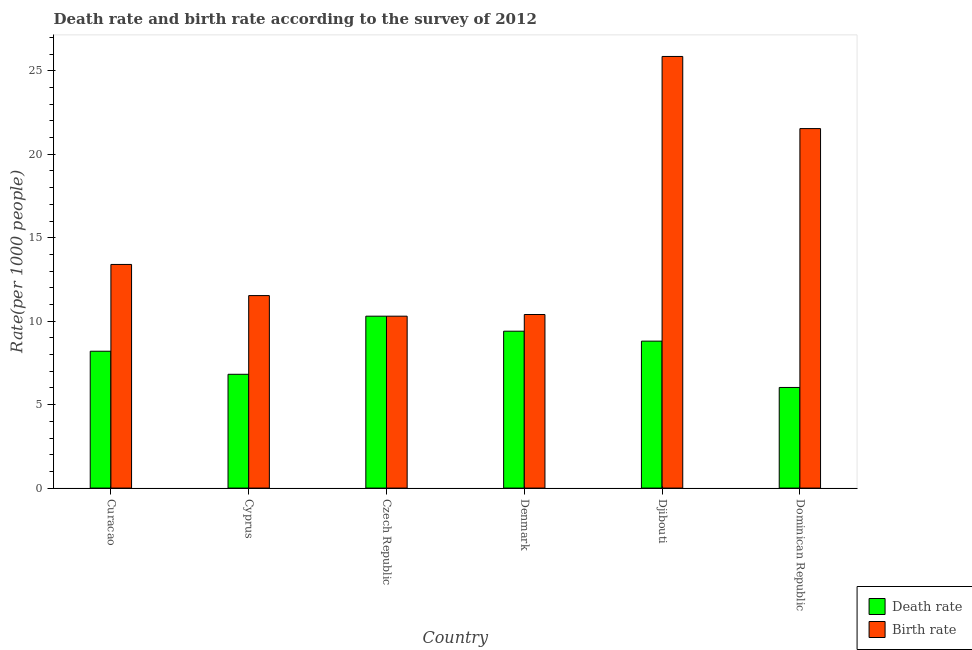How many different coloured bars are there?
Provide a succinct answer. 2. How many bars are there on the 4th tick from the left?
Your response must be concise. 2. How many bars are there on the 6th tick from the right?
Give a very brief answer. 2. What is the label of the 1st group of bars from the left?
Your answer should be compact. Curacao. What is the birth rate in Czech Republic?
Keep it short and to the point. 10.3. Across all countries, what is the maximum death rate?
Provide a succinct answer. 10.3. In which country was the death rate maximum?
Ensure brevity in your answer.  Czech Republic. In which country was the death rate minimum?
Offer a terse response. Dominican Republic. What is the total birth rate in the graph?
Provide a short and direct response. 93.03. What is the difference between the birth rate in Denmark and that in Dominican Republic?
Your answer should be compact. -11.14. What is the difference between the death rate in Curacao and the birth rate in Czech Republic?
Offer a terse response. -2.1. What is the average death rate per country?
Give a very brief answer. 8.26. What is the difference between the death rate and birth rate in Curacao?
Keep it short and to the point. -5.2. What is the ratio of the birth rate in Denmark to that in Dominican Republic?
Provide a succinct answer. 0.48. Is the death rate in Denmark less than that in Dominican Republic?
Your answer should be very brief. No. What is the difference between the highest and the second highest death rate?
Give a very brief answer. 0.9. What is the difference between the highest and the lowest death rate?
Provide a succinct answer. 4.27. Is the sum of the birth rate in Curacao and Djibouti greater than the maximum death rate across all countries?
Offer a terse response. Yes. What does the 1st bar from the left in Denmark represents?
Provide a succinct answer. Death rate. What does the 1st bar from the right in Cyprus represents?
Your answer should be very brief. Birth rate. What is the difference between two consecutive major ticks on the Y-axis?
Provide a succinct answer. 5. Does the graph contain any zero values?
Your answer should be compact. No. How many legend labels are there?
Provide a short and direct response. 2. How are the legend labels stacked?
Your answer should be compact. Vertical. What is the title of the graph?
Offer a very short reply. Death rate and birth rate according to the survey of 2012. What is the label or title of the Y-axis?
Your response must be concise. Rate(per 1000 people). What is the Rate(per 1000 people) of Death rate in Curacao?
Offer a very short reply. 8.2. What is the Rate(per 1000 people) in Birth rate in Curacao?
Ensure brevity in your answer.  13.4. What is the Rate(per 1000 people) of Death rate in Cyprus?
Your answer should be compact. 6.82. What is the Rate(per 1000 people) of Birth rate in Cyprus?
Ensure brevity in your answer.  11.53. What is the Rate(per 1000 people) in Death rate in Czech Republic?
Your answer should be compact. 10.3. What is the Rate(per 1000 people) of Birth rate in Czech Republic?
Offer a terse response. 10.3. What is the Rate(per 1000 people) of Death rate in Djibouti?
Provide a succinct answer. 8.8. What is the Rate(per 1000 people) in Birth rate in Djibouti?
Provide a succinct answer. 25.86. What is the Rate(per 1000 people) in Death rate in Dominican Republic?
Your response must be concise. 6.03. What is the Rate(per 1000 people) in Birth rate in Dominican Republic?
Ensure brevity in your answer.  21.54. Across all countries, what is the maximum Rate(per 1000 people) in Birth rate?
Give a very brief answer. 25.86. Across all countries, what is the minimum Rate(per 1000 people) in Death rate?
Provide a succinct answer. 6.03. Across all countries, what is the minimum Rate(per 1000 people) in Birth rate?
Offer a very short reply. 10.3. What is the total Rate(per 1000 people) in Death rate in the graph?
Offer a terse response. 49.55. What is the total Rate(per 1000 people) of Birth rate in the graph?
Your answer should be very brief. 93.03. What is the difference between the Rate(per 1000 people) in Death rate in Curacao and that in Cyprus?
Provide a succinct answer. 1.38. What is the difference between the Rate(per 1000 people) of Birth rate in Curacao and that in Cyprus?
Your answer should be compact. 1.87. What is the difference between the Rate(per 1000 people) in Death rate in Curacao and that in Czech Republic?
Your response must be concise. -2.1. What is the difference between the Rate(per 1000 people) in Death rate in Curacao and that in Djibouti?
Provide a succinct answer. -0.6. What is the difference between the Rate(per 1000 people) in Birth rate in Curacao and that in Djibouti?
Provide a short and direct response. -12.46. What is the difference between the Rate(per 1000 people) in Death rate in Curacao and that in Dominican Republic?
Your response must be concise. 2.17. What is the difference between the Rate(per 1000 people) of Birth rate in Curacao and that in Dominican Republic?
Offer a very short reply. -8.14. What is the difference between the Rate(per 1000 people) of Death rate in Cyprus and that in Czech Republic?
Provide a succinct answer. -3.48. What is the difference between the Rate(per 1000 people) of Birth rate in Cyprus and that in Czech Republic?
Give a very brief answer. 1.23. What is the difference between the Rate(per 1000 people) in Death rate in Cyprus and that in Denmark?
Ensure brevity in your answer.  -2.58. What is the difference between the Rate(per 1000 people) of Birth rate in Cyprus and that in Denmark?
Provide a succinct answer. 1.13. What is the difference between the Rate(per 1000 people) of Death rate in Cyprus and that in Djibouti?
Offer a very short reply. -1.99. What is the difference between the Rate(per 1000 people) of Birth rate in Cyprus and that in Djibouti?
Ensure brevity in your answer.  -14.33. What is the difference between the Rate(per 1000 people) in Death rate in Cyprus and that in Dominican Republic?
Offer a terse response. 0.79. What is the difference between the Rate(per 1000 people) of Birth rate in Cyprus and that in Dominican Republic?
Your answer should be compact. -10.01. What is the difference between the Rate(per 1000 people) of Birth rate in Czech Republic and that in Denmark?
Make the answer very short. -0.1. What is the difference between the Rate(per 1000 people) in Death rate in Czech Republic and that in Djibouti?
Your answer should be very brief. 1.5. What is the difference between the Rate(per 1000 people) of Birth rate in Czech Republic and that in Djibouti?
Offer a terse response. -15.56. What is the difference between the Rate(per 1000 people) in Death rate in Czech Republic and that in Dominican Republic?
Provide a short and direct response. 4.27. What is the difference between the Rate(per 1000 people) in Birth rate in Czech Republic and that in Dominican Republic?
Give a very brief answer. -11.24. What is the difference between the Rate(per 1000 people) of Death rate in Denmark and that in Djibouti?
Your answer should be very brief. 0.59. What is the difference between the Rate(per 1000 people) in Birth rate in Denmark and that in Djibouti?
Your answer should be very brief. -15.46. What is the difference between the Rate(per 1000 people) in Death rate in Denmark and that in Dominican Republic?
Offer a terse response. 3.37. What is the difference between the Rate(per 1000 people) of Birth rate in Denmark and that in Dominican Republic?
Provide a short and direct response. -11.14. What is the difference between the Rate(per 1000 people) of Death rate in Djibouti and that in Dominican Republic?
Offer a very short reply. 2.78. What is the difference between the Rate(per 1000 people) in Birth rate in Djibouti and that in Dominican Republic?
Ensure brevity in your answer.  4.32. What is the difference between the Rate(per 1000 people) in Death rate in Curacao and the Rate(per 1000 people) in Birth rate in Cyprus?
Ensure brevity in your answer.  -3.33. What is the difference between the Rate(per 1000 people) in Death rate in Curacao and the Rate(per 1000 people) in Birth rate in Djibouti?
Make the answer very short. -17.66. What is the difference between the Rate(per 1000 people) in Death rate in Curacao and the Rate(per 1000 people) in Birth rate in Dominican Republic?
Offer a very short reply. -13.34. What is the difference between the Rate(per 1000 people) of Death rate in Cyprus and the Rate(per 1000 people) of Birth rate in Czech Republic?
Provide a succinct answer. -3.48. What is the difference between the Rate(per 1000 people) of Death rate in Cyprus and the Rate(per 1000 people) of Birth rate in Denmark?
Your answer should be compact. -3.58. What is the difference between the Rate(per 1000 people) in Death rate in Cyprus and the Rate(per 1000 people) in Birth rate in Djibouti?
Make the answer very short. -19.04. What is the difference between the Rate(per 1000 people) of Death rate in Cyprus and the Rate(per 1000 people) of Birth rate in Dominican Republic?
Your answer should be compact. -14.72. What is the difference between the Rate(per 1000 people) of Death rate in Czech Republic and the Rate(per 1000 people) of Birth rate in Djibouti?
Offer a terse response. -15.56. What is the difference between the Rate(per 1000 people) of Death rate in Czech Republic and the Rate(per 1000 people) of Birth rate in Dominican Republic?
Your response must be concise. -11.24. What is the difference between the Rate(per 1000 people) in Death rate in Denmark and the Rate(per 1000 people) in Birth rate in Djibouti?
Your response must be concise. -16.46. What is the difference between the Rate(per 1000 people) of Death rate in Denmark and the Rate(per 1000 people) of Birth rate in Dominican Republic?
Give a very brief answer. -12.14. What is the difference between the Rate(per 1000 people) in Death rate in Djibouti and the Rate(per 1000 people) in Birth rate in Dominican Republic?
Your answer should be compact. -12.73. What is the average Rate(per 1000 people) of Death rate per country?
Provide a succinct answer. 8.26. What is the average Rate(per 1000 people) of Birth rate per country?
Provide a succinct answer. 15.51. What is the difference between the Rate(per 1000 people) in Death rate and Rate(per 1000 people) in Birth rate in Curacao?
Offer a terse response. -5.2. What is the difference between the Rate(per 1000 people) in Death rate and Rate(per 1000 people) in Birth rate in Cyprus?
Ensure brevity in your answer.  -4.72. What is the difference between the Rate(per 1000 people) in Death rate and Rate(per 1000 people) in Birth rate in Czech Republic?
Provide a short and direct response. 0. What is the difference between the Rate(per 1000 people) of Death rate and Rate(per 1000 people) of Birth rate in Djibouti?
Give a very brief answer. -17.06. What is the difference between the Rate(per 1000 people) in Death rate and Rate(per 1000 people) in Birth rate in Dominican Republic?
Make the answer very short. -15.51. What is the ratio of the Rate(per 1000 people) of Death rate in Curacao to that in Cyprus?
Offer a very short reply. 1.2. What is the ratio of the Rate(per 1000 people) in Birth rate in Curacao to that in Cyprus?
Keep it short and to the point. 1.16. What is the ratio of the Rate(per 1000 people) of Death rate in Curacao to that in Czech Republic?
Ensure brevity in your answer.  0.8. What is the ratio of the Rate(per 1000 people) in Birth rate in Curacao to that in Czech Republic?
Provide a succinct answer. 1.3. What is the ratio of the Rate(per 1000 people) of Death rate in Curacao to that in Denmark?
Offer a very short reply. 0.87. What is the ratio of the Rate(per 1000 people) in Birth rate in Curacao to that in Denmark?
Your answer should be compact. 1.29. What is the ratio of the Rate(per 1000 people) of Death rate in Curacao to that in Djibouti?
Ensure brevity in your answer.  0.93. What is the ratio of the Rate(per 1000 people) in Birth rate in Curacao to that in Djibouti?
Offer a terse response. 0.52. What is the ratio of the Rate(per 1000 people) in Death rate in Curacao to that in Dominican Republic?
Give a very brief answer. 1.36. What is the ratio of the Rate(per 1000 people) of Birth rate in Curacao to that in Dominican Republic?
Make the answer very short. 0.62. What is the ratio of the Rate(per 1000 people) of Death rate in Cyprus to that in Czech Republic?
Your answer should be compact. 0.66. What is the ratio of the Rate(per 1000 people) in Birth rate in Cyprus to that in Czech Republic?
Provide a succinct answer. 1.12. What is the ratio of the Rate(per 1000 people) in Death rate in Cyprus to that in Denmark?
Make the answer very short. 0.73. What is the ratio of the Rate(per 1000 people) of Birth rate in Cyprus to that in Denmark?
Your answer should be very brief. 1.11. What is the ratio of the Rate(per 1000 people) of Death rate in Cyprus to that in Djibouti?
Give a very brief answer. 0.77. What is the ratio of the Rate(per 1000 people) of Birth rate in Cyprus to that in Djibouti?
Give a very brief answer. 0.45. What is the ratio of the Rate(per 1000 people) of Death rate in Cyprus to that in Dominican Republic?
Your answer should be compact. 1.13. What is the ratio of the Rate(per 1000 people) of Birth rate in Cyprus to that in Dominican Republic?
Keep it short and to the point. 0.54. What is the ratio of the Rate(per 1000 people) of Death rate in Czech Republic to that in Denmark?
Your response must be concise. 1.1. What is the ratio of the Rate(per 1000 people) in Birth rate in Czech Republic to that in Denmark?
Provide a succinct answer. 0.99. What is the ratio of the Rate(per 1000 people) in Death rate in Czech Republic to that in Djibouti?
Offer a very short reply. 1.17. What is the ratio of the Rate(per 1000 people) of Birth rate in Czech Republic to that in Djibouti?
Provide a succinct answer. 0.4. What is the ratio of the Rate(per 1000 people) in Death rate in Czech Republic to that in Dominican Republic?
Make the answer very short. 1.71. What is the ratio of the Rate(per 1000 people) of Birth rate in Czech Republic to that in Dominican Republic?
Your response must be concise. 0.48. What is the ratio of the Rate(per 1000 people) in Death rate in Denmark to that in Djibouti?
Ensure brevity in your answer.  1.07. What is the ratio of the Rate(per 1000 people) in Birth rate in Denmark to that in Djibouti?
Give a very brief answer. 0.4. What is the ratio of the Rate(per 1000 people) in Death rate in Denmark to that in Dominican Republic?
Ensure brevity in your answer.  1.56. What is the ratio of the Rate(per 1000 people) of Birth rate in Denmark to that in Dominican Republic?
Your response must be concise. 0.48. What is the ratio of the Rate(per 1000 people) of Death rate in Djibouti to that in Dominican Republic?
Keep it short and to the point. 1.46. What is the ratio of the Rate(per 1000 people) of Birth rate in Djibouti to that in Dominican Republic?
Make the answer very short. 1.2. What is the difference between the highest and the second highest Rate(per 1000 people) in Birth rate?
Keep it short and to the point. 4.32. What is the difference between the highest and the lowest Rate(per 1000 people) of Death rate?
Make the answer very short. 4.27. What is the difference between the highest and the lowest Rate(per 1000 people) in Birth rate?
Provide a short and direct response. 15.56. 